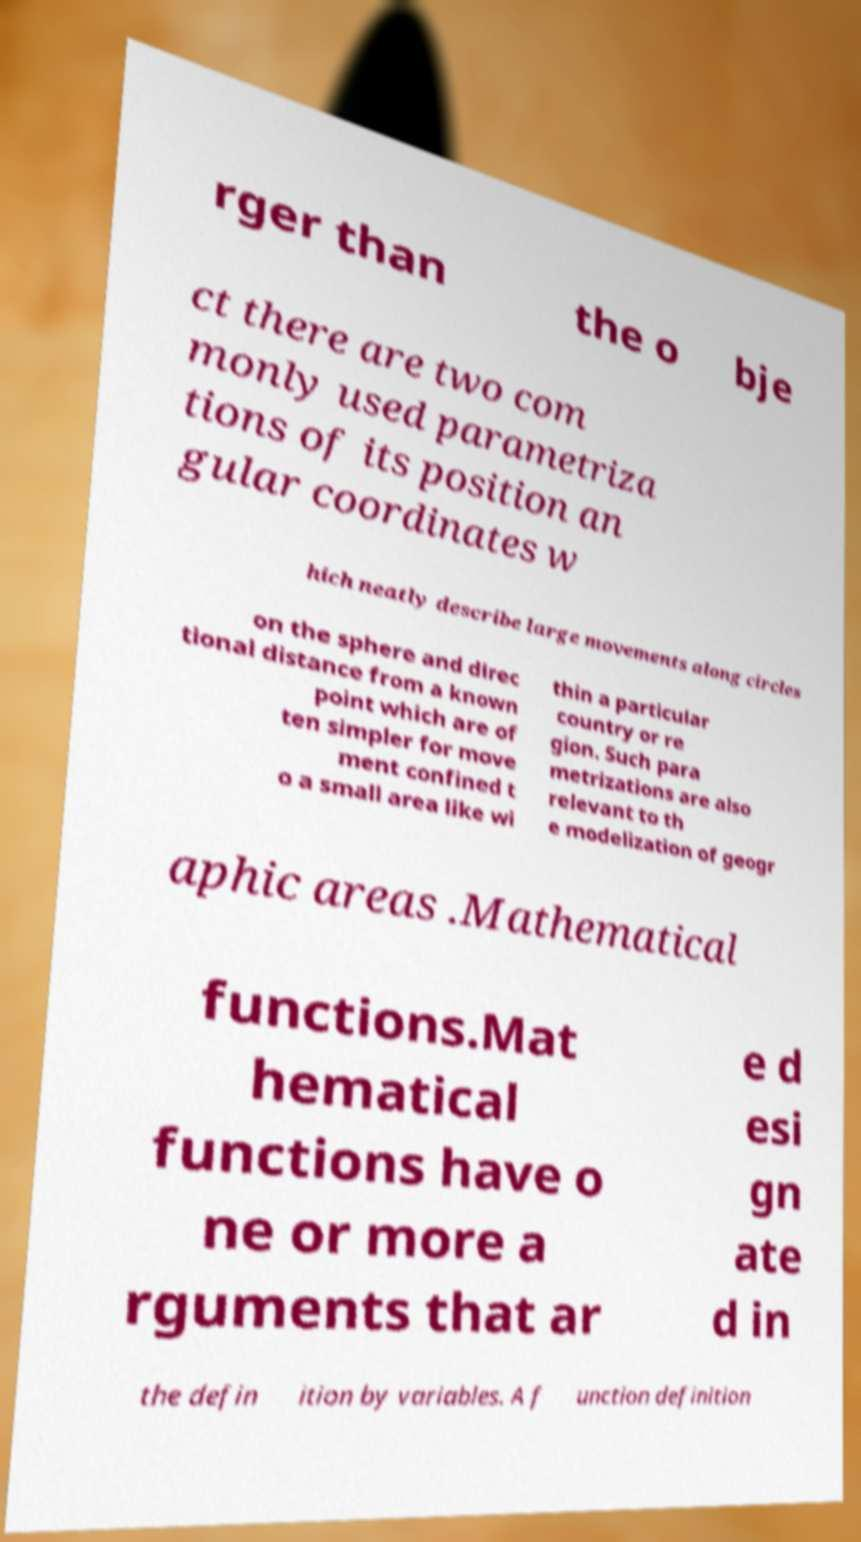Can you accurately transcribe the text from the provided image for me? rger than the o bje ct there are two com monly used parametriza tions of its position an gular coordinates w hich neatly describe large movements along circles on the sphere and direc tional distance from a known point which are of ten simpler for move ment confined t o a small area like wi thin a particular country or re gion. Such para metrizations are also relevant to th e modelization of geogr aphic areas .Mathematical functions.Mat hematical functions have o ne or more a rguments that ar e d esi gn ate d in the defin ition by variables. A f unction definition 